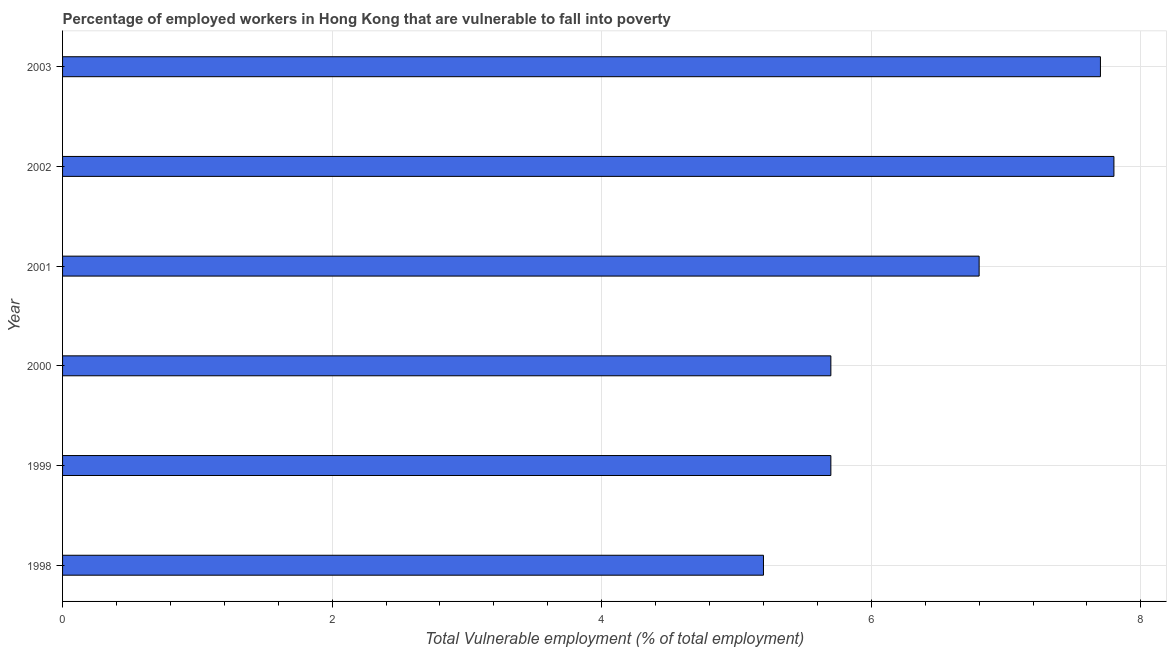Does the graph contain any zero values?
Provide a short and direct response. No. Does the graph contain grids?
Your response must be concise. Yes. What is the title of the graph?
Keep it short and to the point. Percentage of employed workers in Hong Kong that are vulnerable to fall into poverty. What is the label or title of the X-axis?
Your answer should be very brief. Total Vulnerable employment (% of total employment). What is the label or title of the Y-axis?
Your answer should be compact. Year. What is the total vulnerable employment in 2000?
Your answer should be very brief. 5.7. Across all years, what is the maximum total vulnerable employment?
Your answer should be very brief. 7.8. Across all years, what is the minimum total vulnerable employment?
Your answer should be very brief. 5.2. In which year was the total vulnerable employment maximum?
Provide a short and direct response. 2002. What is the sum of the total vulnerable employment?
Make the answer very short. 38.9. What is the difference between the total vulnerable employment in 1999 and 2003?
Your answer should be compact. -2. What is the average total vulnerable employment per year?
Offer a very short reply. 6.48. What is the median total vulnerable employment?
Provide a succinct answer. 6.25. What is the ratio of the total vulnerable employment in 1998 to that in 1999?
Your response must be concise. 0.91. Is the difference between the total vulnerable employment in 1998 and 2000 greater than the difference between any two years?
Provide a succinct answer. No. Is the sum of the total vulnerable employment in 2001 and 2002 greater than the maximum total vulnerable employment across all years?
Your answer should be compact. Yes. In how many years, is the total vulnerable employment greater than the average total vulnerable employment taken over all years?
Offer a very short reply. 3. How many bars are there?
Your response must be concise. 6. Are all the bars in the graph horizontal?
Your response must be concise. Yes. How many years are there in the graph?
Ensure brevity in your answer.  6. What is the difference between two consecutive major ticks on the X-axis?
Make the answer very short. 2. Are the values on the major ticks of X-axis written in scientific E-notation?
Make the answer very short. No. What is the Total Vulnerable employment (% of total employment) of 1998?
Offer a very short reply. 5.2. What is the Total Vulnerable employment (% of total employment) of 1999?
Your answer should be very brief. 5.7. What is the Total Vulnerable employment (% of total employment) in 2000?
Offer a terse response. 5.7. What is the Total Vulnerable employment (% of total employment) in 2001?
Ensure brevity in your answer.  6.8. What is the Total Vulnerable employment (% of total employment) of 2002?
Give a very brief answer. 7.8. What is the Total Vulnerable employment (% of total employment) in 2003?
Ensure brevity in your answer.  7.7. What is the difference between the Total Vulnerable employment (% of total employment) in 1998 and 1999?
Offer a terse response. -0.5. What is the difference between the Total Vulnerable employment (% of total employment) in 1998 and 2001?
Offer a very short reply. -1.6. What is the difference between the Total Vulnerable employment (% of total employment) in 1998 and 2002?
Your response must be concise. -2.6. What is the difference between the Total Vulnerable employment (% of total employment) in 1999 and 2001?
Offer a very short reply. -1.1. What is the difference between the Total Vulnerable employment (% of total employment) in 2000 and 2001?
Offer a very short reply. -1.1. What is the difference between the Total Vulnerable employment (% of total employment) in 2000 and 2003?
Provide a succinct answer. -2. What is the difference between the Total Vulnerable employment (% of total employment) in 2001 and 2002?
Your response must be concise. -1. What is the difference between the Total Vulnerable employment (% of total employment) in 2002 and 2003?
Offer a terse response. 0.1. What is the ratio of the Total Vulnerable employment (% of total employment) in 1998 to that in 1999?
Your answer should be very brief. 0.91. What is the ratio of the Total Vulnerable employment (% of total employment) in 1998 to that in 2000?
Offer a terse response. 0.91. What is the ratio of the Total Vulnerable employment (% of total employment) in 1998 to that in 2001?
Make the answer very short. 0.77. What is the ratio of the Total Vulnerable employment (% of total employment) in 1998 to that in 2002?
Make the answer very short. 0.67. What is the ratio of the Total Vulnerable employment (% of total employment) in 1998 to that in 2003?
Your answer should be very brief. 0.68. What is the ratio of the Total Vulnerable employment (% of total employment) in 1999 to that in 2001?
Give a very brief answer. 0.84. What is the ratio of the Total Vulnerable employment (% of total employment) in 1999 to that in 2002?
Ensure brevity in your answer.  0.73. What is the ratio of the Total Vulnerable employment (% of total employment) in 1999 to that in 2003?
Keep it short and to the point. 0.74. What is the ratio of the Total Vulnerable employment (% of total employment) in 2000 to that in 2001?
Make the answer very short. 0.84. What is the ratio of the Total Vulnerable employment (% of total employment) in 2000 to that in 2002?
Keep it short and to the point. 0.73. What is the ratio of the Total Vulnerable employment (% of total employment) in 2000 to that in 2003?
Your answer should be very brief. 0.74. What is the ratio of the Total Vulnerable employment (% of total employment) in 2001 to that in 2002?
Offer a very short reply. 0.87. What is the ratio of the Total Vulnerable employment (% of total employment) in 2001 to that in 2003?
Give a very brief answer. 0.88. What is the ratio of the Total Vulnerable employment (% of total employment) in 2002 to that in 2003?
Your answer should be very brief. 1.01. 